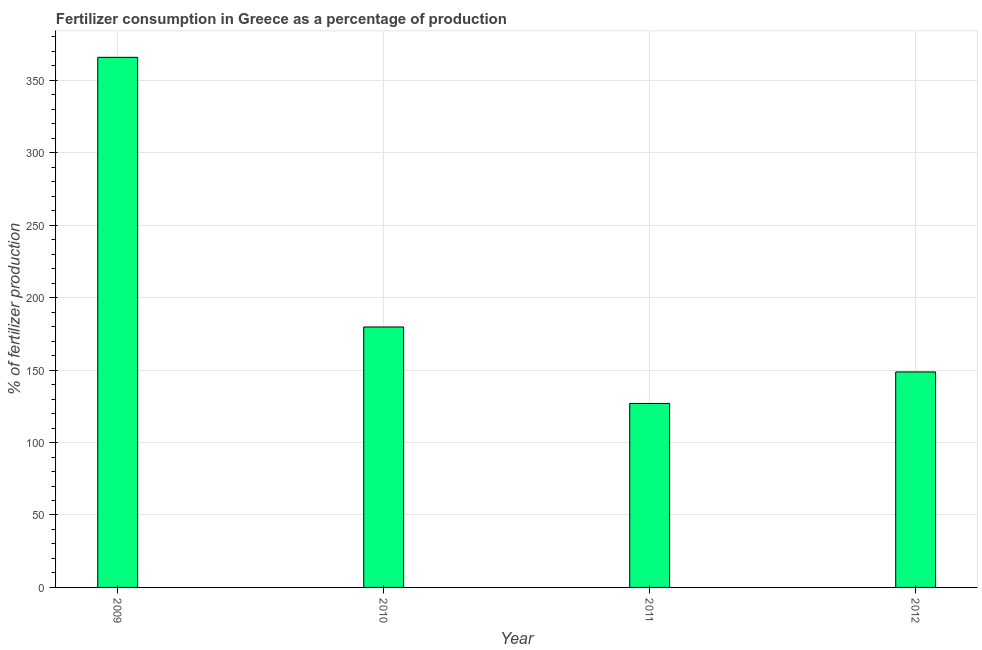Does the graph contain grids?
Offer a terse response. Yes. What is the title of the graph?
Keep it short and to the point. Fertilizer consumption in Greece as a percentage of production. What is the label or title of the Y-axis?
Your answer should be compact. % of fertilizer production. What is the amount of fertilizer consumption in 2011?
Your answer should be compact. 126.98. Across all years, what is the maximum amount of fertilizer consumption?
Offer a terse response. 365.89. Across all years, what is the minimum amount of fertilizer consumption?
Ensure brevity in your answer.  126.98. In which year was the amount of fertilizer consumption maximum?
Your answer should be very brief. 2009. In which year was the amount of fertilizer consumption minimum?
Make the answer very short. 2011. What is the sum of the amount of fertilizer consumption?
Keep it short and to the point. 821.38. What is the difference between the amount of fertilizer consumption in 2009 and 2011?
Give a very brief answer. 238.91. What is the average amount of fertilizer consumption per year?
Offer a very short reply. 205.34. What is the median amount of fertilizer consumption?
Make the answer very short. 164.25. What is the ratio of the amount of fertilizer consumption in 2009 to that in 2010?
Your answer should be compact. 2.04. Is the amount of fertilizer consumption in 2009 less than that in 2010?
Your response must be concise. No. What is the difference between the highest and the second highest amount of fertilizer consumption?
Ensure brevity in your answer.  186.12. Is the sum of the amount of fertilizer consumption in 2009 and 2011 greater than the maximum amount of fertilizer consumption across all years?
Your answer should be very brief. Yes. What is the difference between the highest and the lowest amount of fertilizer consumption?
Your answer should be compact. 238.9. In how many years, is the amount of fertilizer consumption greater than the average amount of fertilizer consumption taken over all years?
Offer a terse response. 1. How many bars are there?
Your answer should be very brief. 4. Are all the bars in the graph horizontal?
Your answer should be compact. No. What is the difference between two consecutive major ticks on the Y-axis?
Offer a very short reply. 50. What is the % of fertilizer production of 2009?
Provide a succinct answer. 365.89. What is the % of fertilizer production of 2010?
Offer a very short reply. 179.77. What is the % of fertilizer production of 2011?
Offer a very short reply. 126.98. What is the % of fertilizer production in 2012?
Your response must be concise. 148.73. What is the difference between the % of fertilizer production in 2009 and 2010?
Keep it short and to the point. 186.12. What is the difference between the % of fertilizer production in 2009 and 2011?
Your answer should be very brief. 238.9. What is the difference between the % of fertilizer production in 2009 and 2012?
Offer a terse response. 217.16. What is the difference between the % of fertilizer production in 2010 and 2011?
Offer a very short reply. 52.79. What is the difference between the % of fertilizer production in 2010 and 2012?
Give a very brief answer. 31.04. What is the difference between the % of fertilizer production in 2011 and 2012?
Ensure brevity in your answer.  -21.75. What is the ratio of the % of fertilizer production in 2009 to that in 2010?
Ensure brevity in your answer.  2.04. What is the ratio of the % of fertilizer production in 2009 to that in 2011?
Offer a terse response. 2.88. What is the ratio of the % of fertilizer production in 2009 to that in 2012?
Provide a succinct answer. 2.46. What is the ratio of the % of fertilizer production in 2010 to that in 2011?
Offer a very short reply. 1.42. What is the ratio of the % of fertilizer production in 2010 to that in 2012?
Your answer should be compact. 1.21. What is the ratio of the % of fertilizer production in 2011 to that in 2012?
Your answer should be very brief. 0.85. 